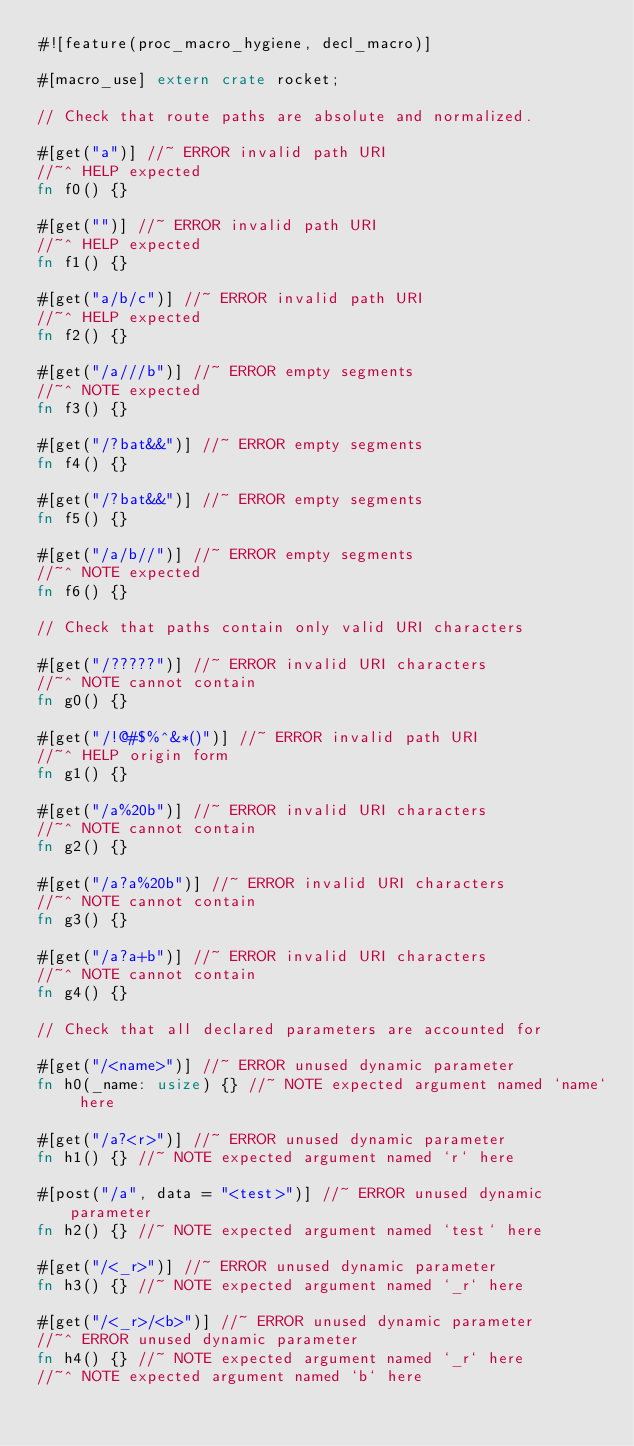Convert code to text. <code><loc_0><loc_0><loc_500><loc_500><_Rust_>#![feature(proc_macro_hygiene, decl_macro)]

#[macro_use] extern crate rocket;

// Check that route paths are absolute and normalized.

#[get("a")] //~ ERROR invalid path URI
//~^ HELP expected
fn f0() {}

#[get("")] //~ ERROR invalid path URI
//~^ HELP expected
fn f1() {}

#[get("a/b/c")] //~ ERROR invalid path URI
//~^ HELP expected
fn f2() {}

#[get("/a///b")] //~ ERROR empty segments
//~^ NOTE expected
fn f3() {}

#[get("/?bat&&")] //~ ERROR empty segments
fn f4() {}

#[get("/?bat&&")] //~ ERROR empty segments
fn f5() {}

#[get("/a/b//")] //~ ERROR empty segments
//~^ NOTE expected
fn f6() {}

// Check that paths contain only valid URI characters

#[get("/?????")] //~ ERROR invalid URI characters
//~^ NOTE cannot contain
fn g0() {}

#[get("/!@#$%^&*()")] //~ ERROR invalid path URI
//~^ HELP origin form
fn g1() {}

#[get("/a%20b")] //~ ERROR invalid URI characters
//~^ NOTE cannot contain
fn g2() {}

#[get("/a?a%20b")] //~ ERROR invalid URI characters
//~^ NOTE cannot contain
fn g3() {}

#[get("/a?a+b")] //~ ERROR invalid URI characters
//~^ NOTE cannot contain
fn g4() {}

// Check that all declared parameters are accounted for

#[get("/<name>")] //~ ERROR unused dynamic parameter
fn h0(_name: usize) {} //~ NOTE expected argument named `name` here

#[get("/a?<r>")] //~ ERROR unused dynamic parameter
fn h1() {} //~ NOTE expected argument named `r` here

#[post("/a", data = "<test>")] //~ ERROR unused dynamic parameter
fn h2() {} //~ NOTE expected argument named `test` here

#[get("/<_r>")] //~ ERROR unused dynamic parameter
fn h3() {} //~ NOTE expected argument named `_r` here

#[get("/<_r>/<b>")] //~ ERROR unused dynamic parameter
//~^ ERROR unused dynamic parameter
fn h4() {} //~ NOTE expected argument named `_r` here
//~^ NOTE expected argument named `b` here
</code> 